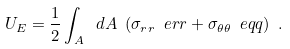Convert formula to latex. <formula><loc_0><loc_0><loc_500><loc_500>U _ { E } = \frac { 1 } { 2 } \int _ { A } \ d A \ ( \sigma _ { r r } \ e r r + \sigma _ { \theta \theta } \ e q q ) \ .</formula> 